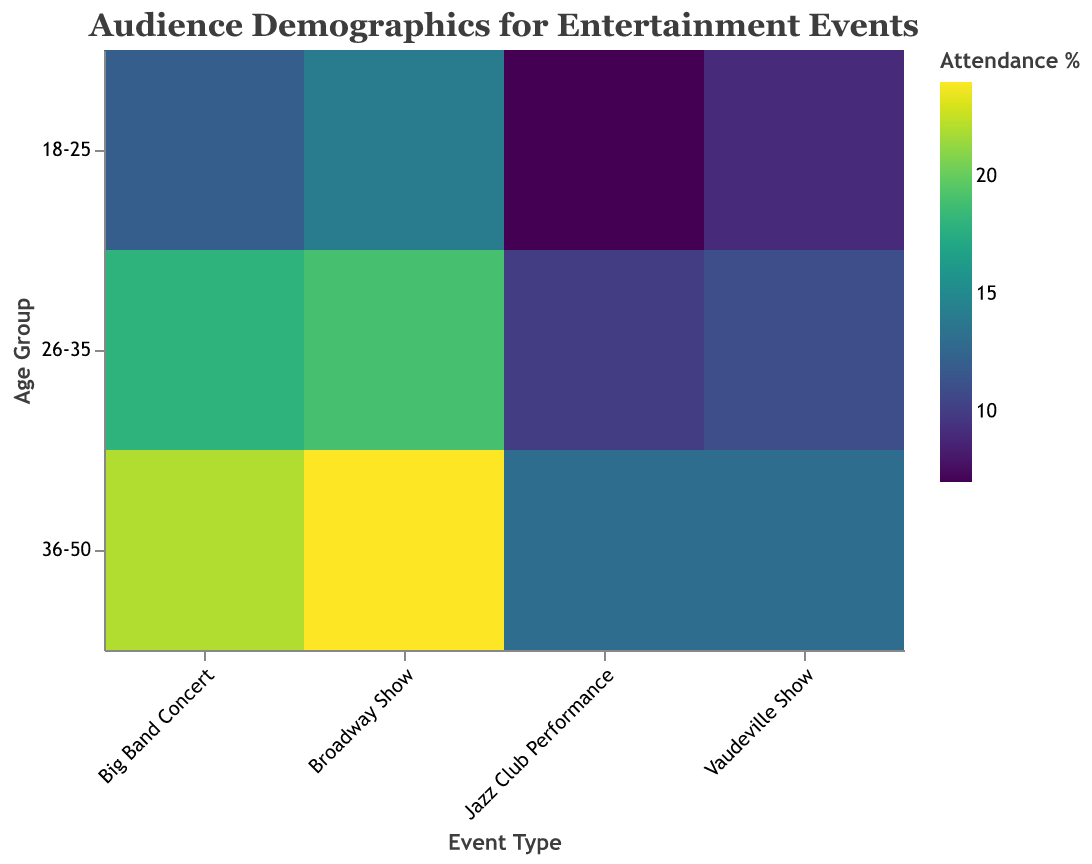What is the title of the heatmap? Look at the top of the figure. The title should be clearly mentioned.
Answer: Audience Demographics for Entertainment Events Which event type has the highest attendance percentage in the 36-50 age group? Examine the colors in the figure, particularly in the row for 36-50 age group. The darkest color indicates the highest attendance percentage.
Answer: Broadway Show What is the attendance percentage for Female audiences at Jazz Club Performances aged 18-25 in Illinois? Look for the cell under Jazz Club Performance event type and 18-25 age group with Female gender.
Answer: 10 Which gender has a higher attendance percentage for Big Band Concerts in the 26-35 age group in California? Compare the attendance percentages of Male and Female under Big Band Concert for 26-35 age group in California.
Answer: Female What is the average attendance percentage for Vaudeville Shows in the 18-25 age group in New York? Add the attendance percentages for Male (9) and Female (11), then divide by 2. (9 + 11)/2 = 10
Answer: 10 Among all the event types and age groups, which specific combination has the lowest attendance percentage? Identify the cell with the lightest color, indicating the lowest attendance percentage.
Answer: Broadway Show, 18-25, Male, 8 How does the attendance percentage for Female audiences at Broadway Shows in the 26-35 age group compare to Male audiences in the same category? Compare the attendance percentages of Male (9) and Female (19) under Broadway Shows for 26-35 age group.
Answer: Female is higher Which age group and event type combination has the highest attendance percentage in the entire heatmap? Identify the cell with the darkest color, indicating the highest attendance percentage.
Answer: Broadway Show, 36-50, Female, 24 How many age group categories are represented in the heatmap? Count the distinct age group labels on the y-axis.
Answer: 3 Which city or state appears most frequently across different events and age groups? Calculate the frequency of each city or state based on the tooltip data and check the highest occurrence.
Answer: California 